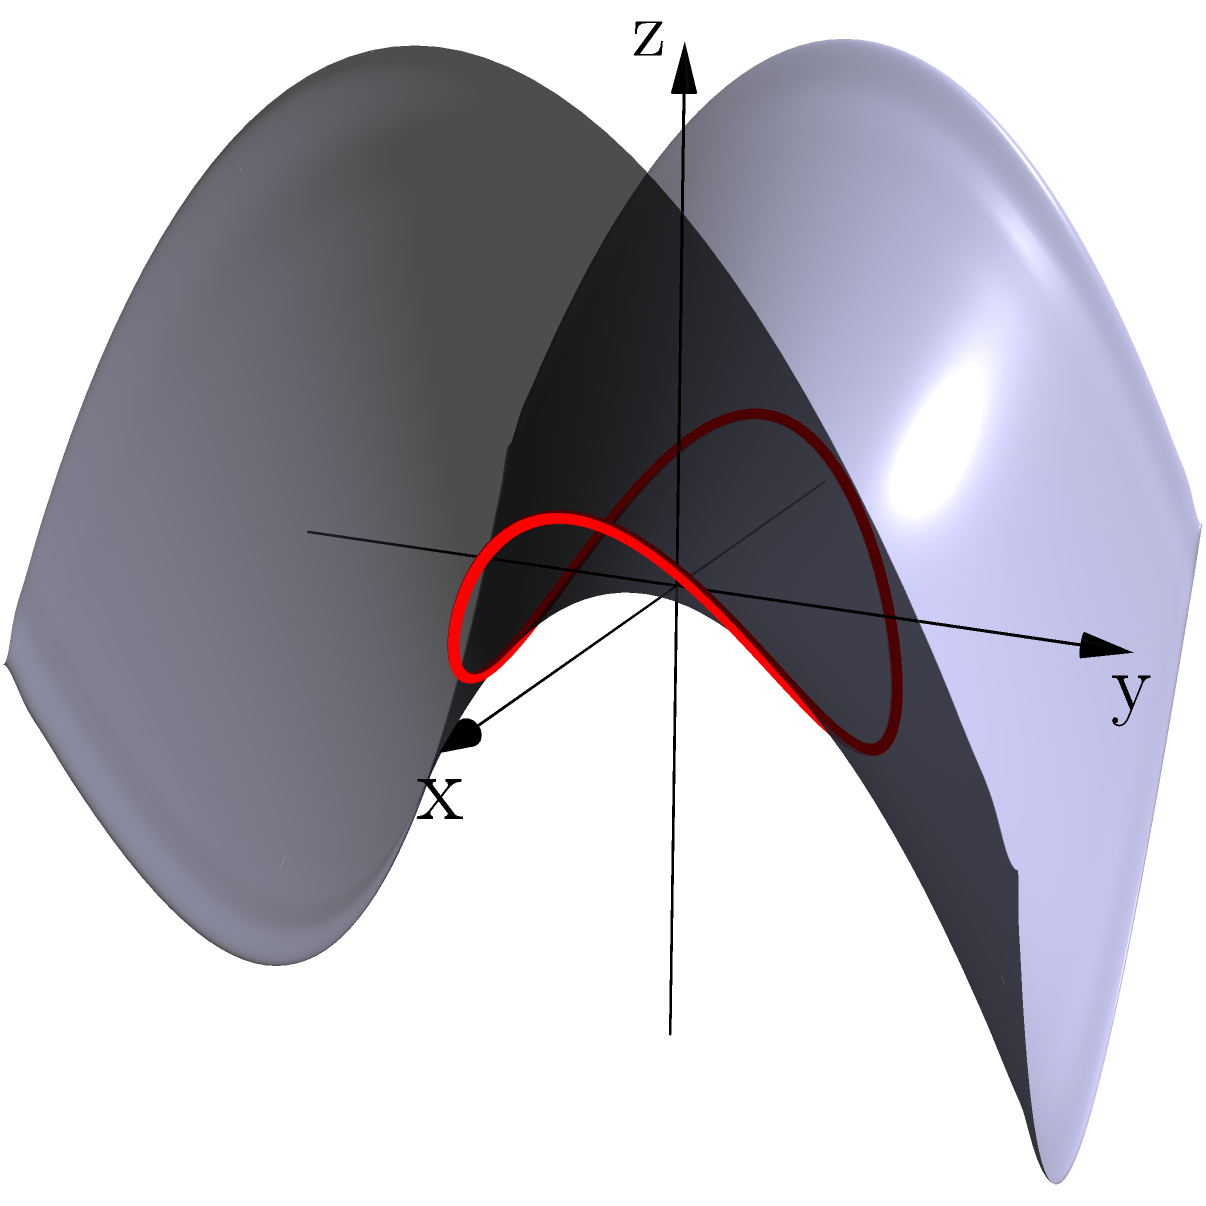In the context of creating unique nail decals inspired by Non-Euclidean Geometry, consider a saddle-shaped surface described by the equation $z = \frac{1}{2}(x^2 - y^2)$. A geodesic on this surface follows a circular path when projected onto the xy-plane. What is the significance of this geodesic's behavior for nail art design, and how does it differ from a straight line on a flat surface? To understand the significance of this geodesic for nail art design, let's break down the problem step-by-step:

1. Surface equation: The saddle-shaped surface is described by $z = \frac{1}{2}(x^2 - y^2)$. This is a hyperbolic paraboloid, which has negative Gaussian curvature.

2. Geodesic behavior: On this surface, a geodesic that projects to a circle on the xy-plane is shown in red on the diagram. This is different from a flat surface, where geodesics are straight lines.

3. Curvature effects: The negative curvature of the saddle surface causes the geodesic to curve in ways that may appear counterintuitive when compared to flat surfaces.

4. Nail art application:
   a) Unique patterns: The curved geodesic can inspire intricate, curving patterns for nail decals that follow the "shortest path" on a saddle-shaped surface.
   b) Optical illusion: When applied to a flat nail, these curved patterns can create the illusion of depth and non-Euclidean geometry.
   c) Mathematical art: Incorporating these geodesics in nail art can showcase the beauty of mathematical concepts in a wearable form.

5. Contrast with flat surfaces: On a flat surface, the shortest path between two points is always a straight line. The curved geodesic on the saddle surface demonstrates how geometry changes in non-Euclidean spaces.

6. Design possibilities: By varying the parameters of the surface equation or choosing different geodesics, a wide range of curved patterns can be generated for diverse nail art designs.

This geodesic behavior offers a unique opportunity to create nail decals that are not only visually striking but also mathematically interesting, bridging the gap between abstract geometry and practical aesthetics.
Answer: Curved geodesics inspire unique, mathematically-based nail art patterns that create illusions of depth and non-Euclidean geometry when applied to flat nails. 